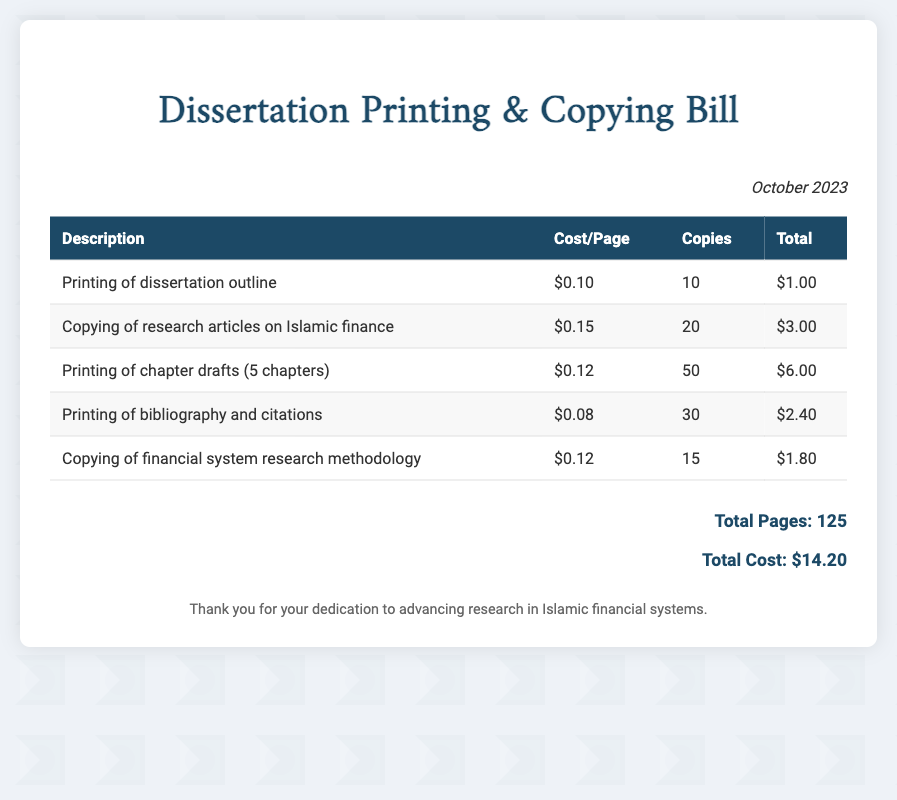what is the date of the bill? The date of the bill is mentioned in the document as October 2023.
Answer: October 2023 what is the cost per page for copying research articles on Islamic finance? The cost per page for copying research articles is listed as $0.15.
Answer: $0.15 how many copies were made of the dissertation outline? The document states that 10 copies were made of the dissertation outline.
Answer: 10 what is the total cost for printing the chapter drafts? The total cost for printing chapter drafts, as indicated in the bill, is $6.00.
Answer: $6.00 what is the total number of pages included in the bill? The total number of pages printed and copied, as calculated in the document, is 125.
Answer: 125 what is the total cost of the bill? The total cost of the bill is summed up and stated as $14.20.
Answer: $14.20 what type of document is this? The document is a bill specifically for printing and copying costs related to dissertation preparation.
Answer: Bill how much was spent on printing bibliography and citations? The document lists the cost spent on printing bibliography and citations as $2.40.
Answer: $2.40 how many chapters were included in the printing of chapter drafts? The document indicates that 5 chapters were included in the printing of chapter drafts.
Answer: 5 